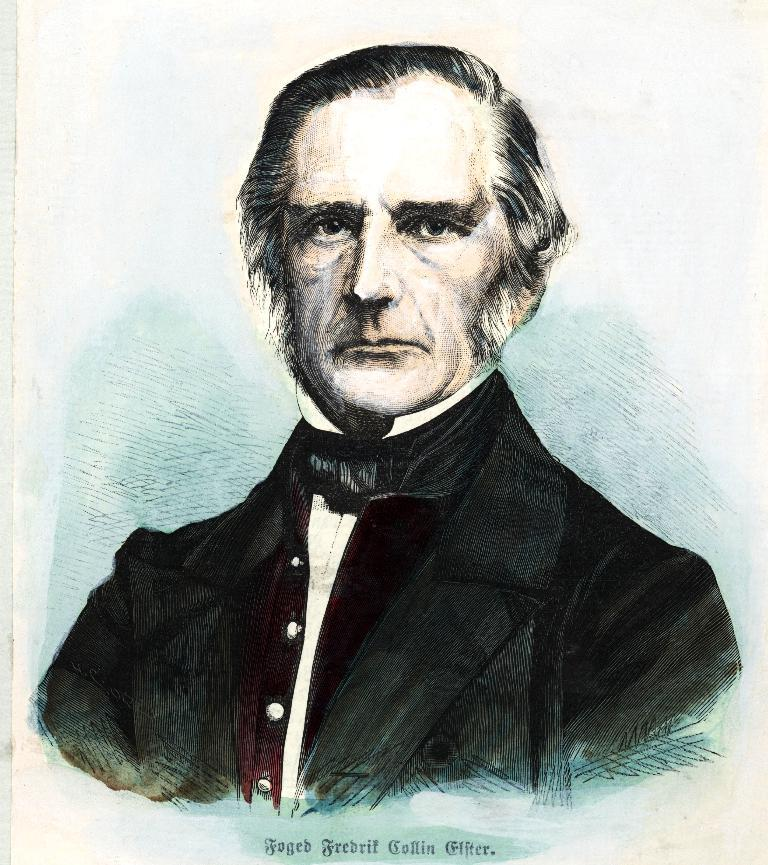What type of image is being described? The image is an art piece. Can you describe the main subject of the art piece? There is a man in the middle of the image. What is the man wearing in the image? The man is wearing a suit, a shirt, and a tie. Is there any text present in the image? Yes, there is text at the bottom of the image. What type of ice can be seen melting on the man's tie in the image? There is no ice present in the image, and the man's tie does not have any ice on it. 